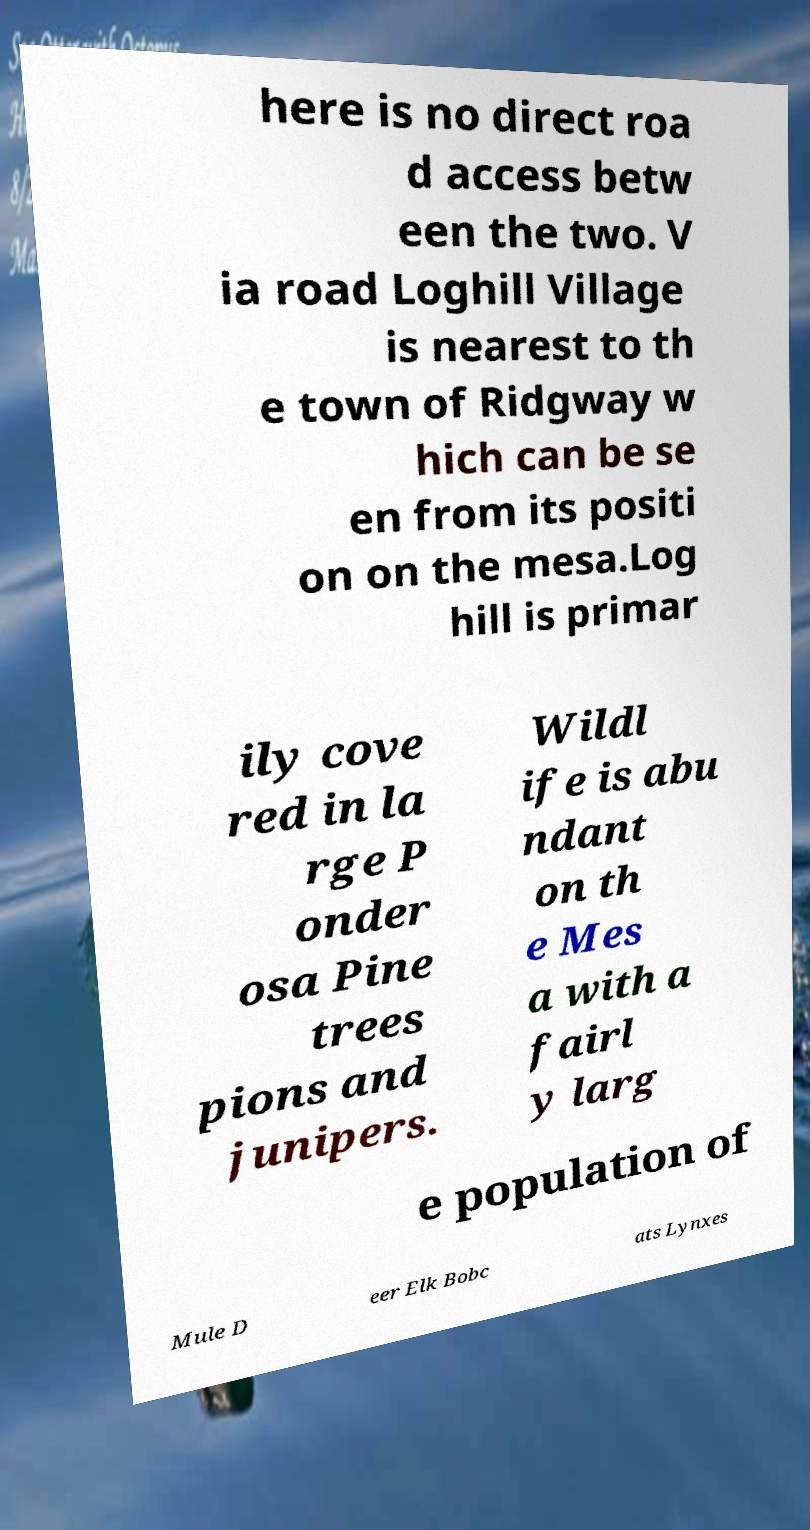What messages or text are displayed in this image? I need them in a readable, typed format. here is no direct roa d access betw een the two. V ia road Loghill Village is nearest to th e town of Ridgway w hich can be se en from its positi on on the mesa.Log hill is primar ily cove red in la rge P onder osa Pine trees pions and junipers. Wildl ife is abu ndant on th e Mes a with a fairl y larg e population of Mule D eer Elk Bobc ats Lynxes 